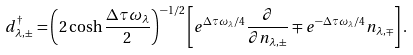<formula> <loc_0><loc_0><loc_500><loc_500>d _ { \lambda , \pm } ^ { \dagger } = \left ( 2 \cosh \frac { \Delta \tau \omega _ { \lambda } } { 2 } \right ) ^ { - 1 / 2 } \left [ e ^ { \Delta \tau \omega _ { \lambda } / 4 } \frac { \partial } { \partial n _ { \lambda , \pm } } \mp e ^ { - \Delta \tau \omega _ { \lambda } / 4 } n _ { \lambda , \mp } \right ] .</formula> 